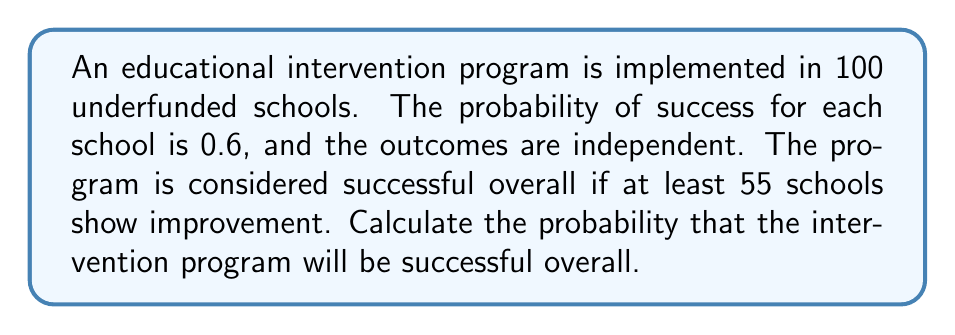Can you solve this math problem? This problem can be solved using the binomial distribution. Let's approach it step-by-step:

1) We have a binomial experiment with:
   $n = 100$ (number of schools)
   $p = 0.6$ (probability of success for each school)
   $X = $ number of successful schools
   We need to find $P(X \geq 55)$

2) The probability mass function for a binomial distribution is:
   $$P(X = k) = \binom{n}{k} p^k (1-p)^{n-k}$$

3) We need to sum this for all $k$ from 55 to 100:
   $$P(X \geq 55) = \sum_{k=55}^{100} \binom{100}{k} (0.6)^k (0.4)^{100-k}$$

4) This sum is computationally intensive, so we can use the normal approximation to the binomial distribution when $np$ and $n(1-p)$ are both greater than 5. Here, $np = 100(0.6) = 60$ and $n(1-p) = 100(0.4) = 40$, so we can use the approximation.

5) For a normal approximation:
   $\mu = np = 100(0.6) = 60$
   $\sigma = \sqrt{np(1-p)} = \sqrt{100(0.6)(0.4)} = 4.90$

6) We need to find $P(X \geq 54.5)$ due to continuity correction:
   $z = \frac{54.5 - 60}{4.90} = -1.12$

7) Using a standard normal table or calculator, we find:
   $P(Z > -1.12) = 1 - P(Z < -1.12) = 1 - 0.1314 = 0.8686$

Therefore, the probability that the intervention program will be successful overall is approximately 0.8686 or 86.86%.
Answer: $0.8686$ 